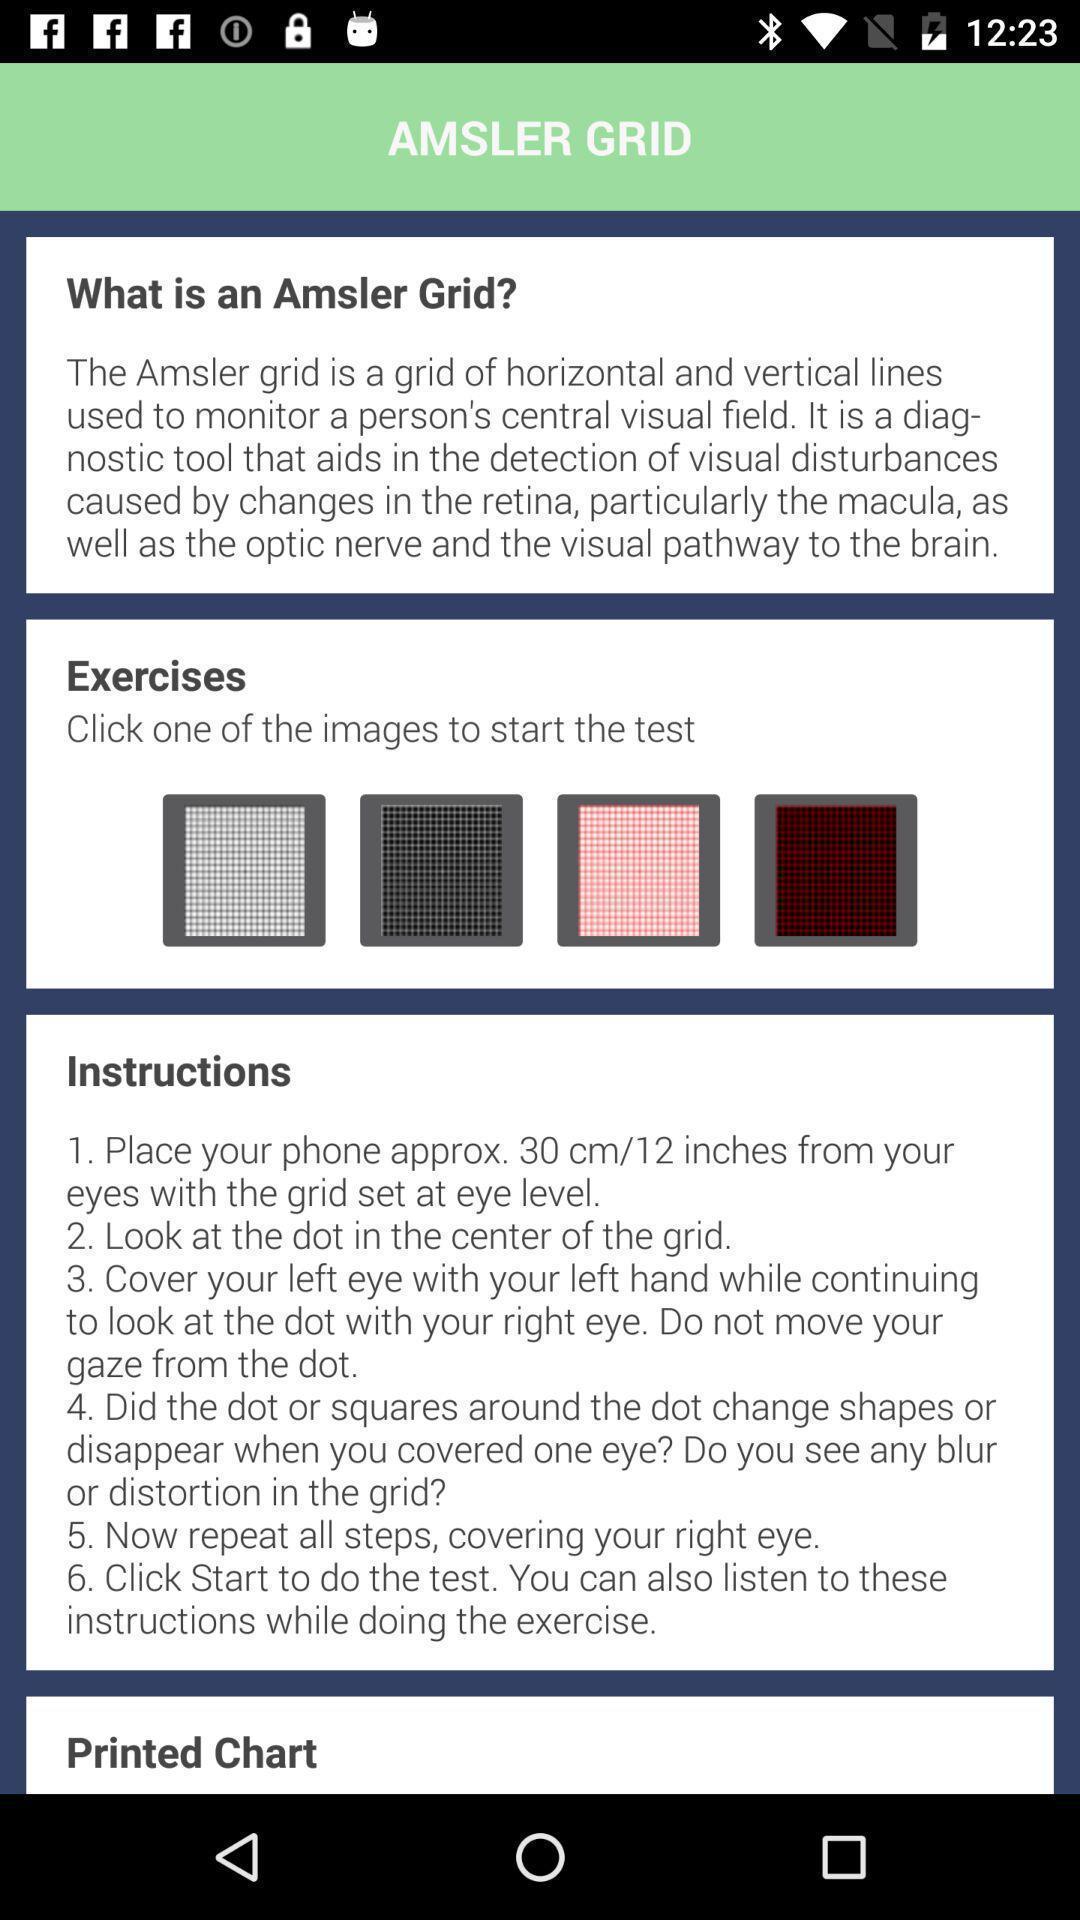Describe the visual elements of this screenshot. Screen showing list of instructions of a health app. 